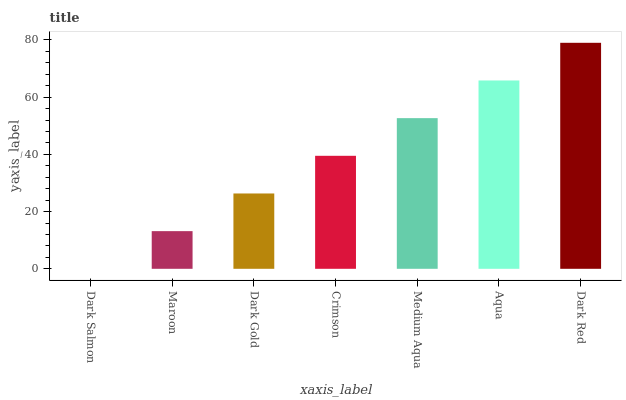Is Dark Salmon the minimum?
Answer yes or no. Yes. Is Dark Red the maximum?
Answer yes or no. Yes. Is Maroon the minimum?
Answer yes or no. No. Is Maroon the maximum?
Answer yes or no. No. Is Maroon greater than Dark Salmon?
Answer yes or no. Yes. Is Dark Salmon less than Maroon?
Answer yes or no. Yes. Is Dark Salmon greater than Maroon?
Answer yes or no. No. Is Maroon less than Dark Salmon?
Answer yes or no. No. Is Crimson the high median?
Answer yes or no. Yes. Is Crimson the low median?
Answer yes or no. Yes. Is Dark Red the high median?
Answer yes or no. No. Is Medium Aqua the low median?
Answer yes or no. No. 